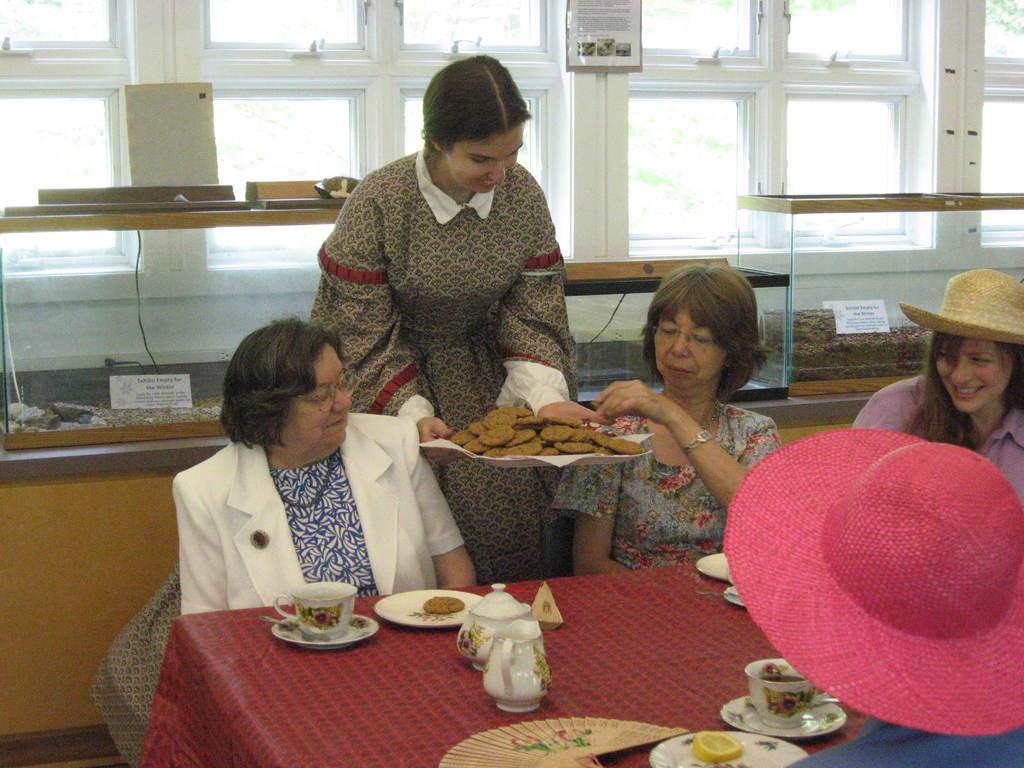In one or two sentences, can you explain what this image depicts? This image consists of a table and window on the backside. There are women in this image. All of them are sitting around a table. The table consists of a cup, saucer, plate, jar, edibles. There is a woman in the middle, she is holding a plate. 